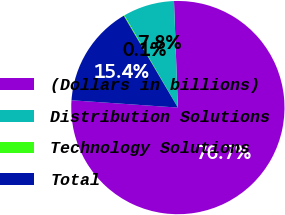Convert chart. <chart><loc_0><loc_0><loc_500><loc_500><pie_chart><fcel>(Dollars in billions)<fcel>Distribution Solutions<fcel>Technology Solutions<fcel>Total<nl><fcel>76.67%<fcel>7.78%<fcel>0.12%<fcel>15.43%<nl></chart> 